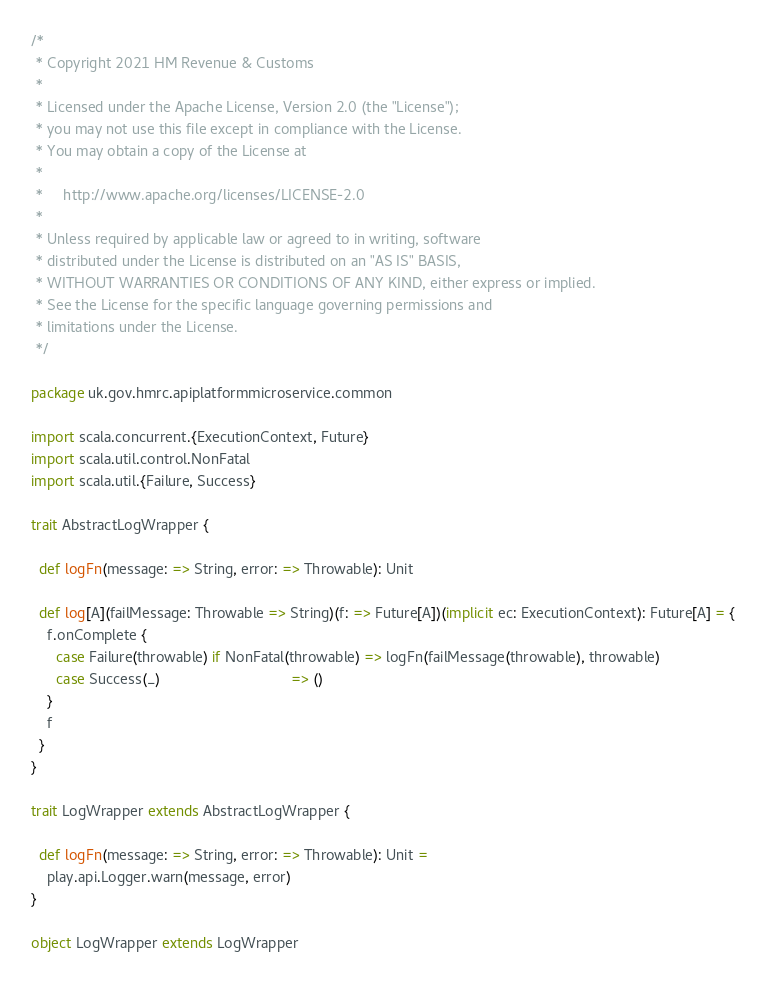Convert code to text. <code><loc_0><loc_0><loc_500><loc_500><_Scala_>/*
 * Copyright 2021 HM Revenue & Customs
 *
 * Licensed under the Apache License, Version 2.0 (the "License");
 * you may not use this file except in compliance with the License.
 * You may obtain a copy of the License at
 *
 *     http://www.apache.org/licenses/LICENSE-2.0
 *
 * Unless required by applicable law or agreed to in writing, software
 * distributed under the License is distributed on an "AS IS" BASIS,
 * WITHOUT WARRANTIES OR CONDITIONS OF ANY KIND, either express or implied.
 * See the License for the specific language governing permissions and
 * limitations under the License.
 */

package uk.gov.hmrc.apiplatformmicroservice.common

import scala.concurrent.{ExecutionContext, Future}
import scala.util.control.NonFatal
import scala.util.{Failure, Success}

trait AbstractLogWrapper {

  def logFn(message: => String, error: => Throwable): Unit

  def log[A](failMessage: Throwable => String)(f: => Future[A])(implicit ec: ExecutionContext): Future[A] = {
    f.onComplete {
      case Failure(throwable) if NonFatal(throwable) => logFn(failMessage(throwable), throwable)
      case Success(_)                                => ()
    }
    f
  }
}

trait LogWrapper extends AbstractLogWrapper {

  def logFn(message: => String, error: => Throwable): Unit =
    play.api.Logger.warn(message, error)
}

object LogWrapper extends LogWrapper
</code> 